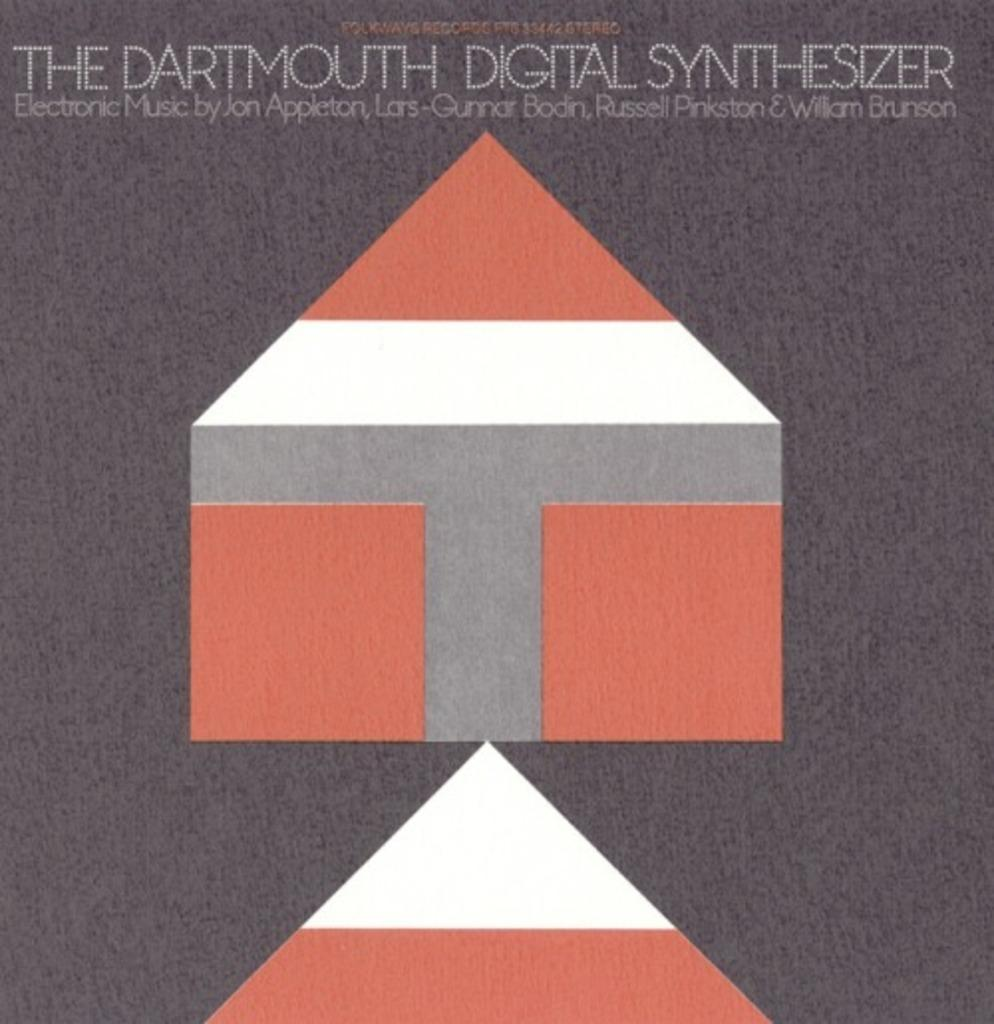<image>
Relay a brief, clear account of the picture shown. The picture shown advertises electronic music by Jon Appleton. 